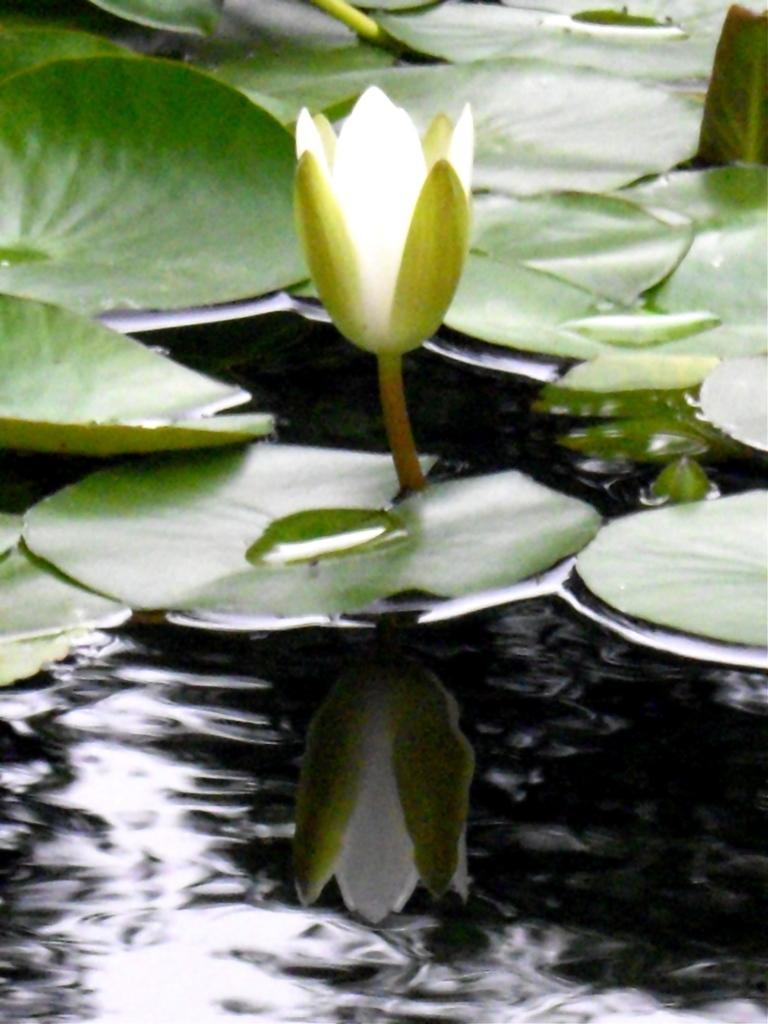Could you give a brief overview of what you see in this image? In the image there is a lotus flower in the water surface and around that flower there are many leaves. 